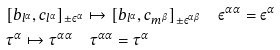<formula> <loc_0><loc_0><loc_500><loc_500>& [ b _ { l ^ { \alpha } } , c _ { l ^ { \alpha } } ] _ { \pm \varepsilon ^ { \alpha } } \mapsto [ b _ { l ^ { \alpha } } , c _ { m ^ { \beta } } ] _ { \pm \varepsilon ^ { \alpha \beta } } \quad \varepsilon ^ { \alpha \alpha } = \varepsilon ^ { \alpha } \\ & \tau ^ { \alpha } \mapsto \tau ^ { \alpha \alpha } \quad \tau ^ { \alpha \alpha } = \tau ^ { \alpha }</formula> 